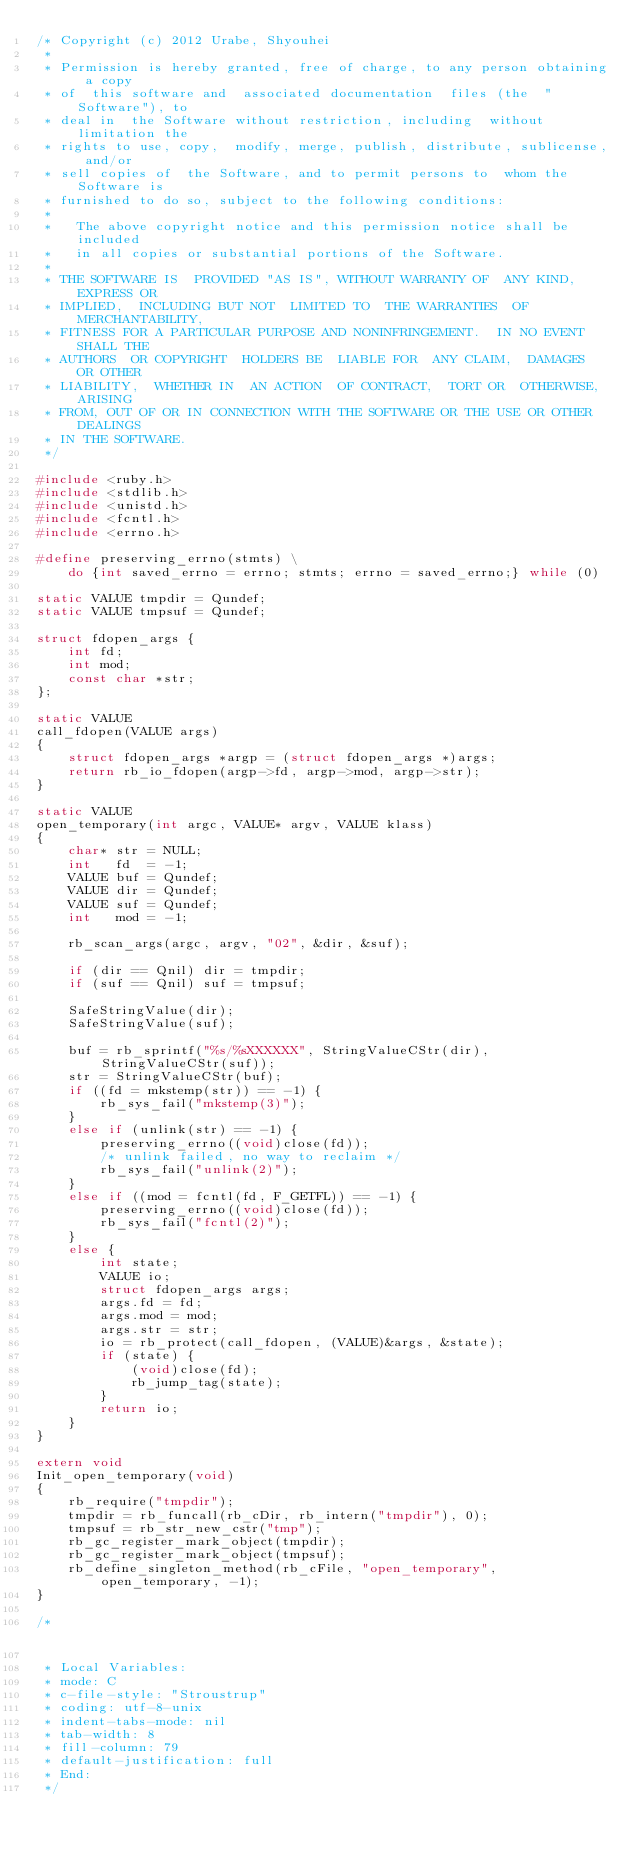<code> <loc_0><loc_0><loc_500><loc_500><_C_>/* Copyright (c) 2012 Urabe, Shyouhei
 *
 * Permission is hereby granted, free of charge, to any person obtaining a copy
 * of  this software and  associated documentation  files (the  "Software"), to
 * deal in  the Software without restriction, including  without limitation the
 * rights to use, copy,  modify, merge, publish, distribute, sublicense, and/or
 * sell copies of  the Software, and to permit persons to  whom the Software is
 * furnished to do so, subject to the following conditions:
 *
 *   The above copyright notice and this permission notice shall be included
 *   in all copies or substantial portions of the Software.
 *
 * THE SOFTWARE IS  PROVIDED "AS IS", WITHOUT WARRANTY OF  ANY KIND, EXPRESS OR
 * IMPLIED,  INCLUDING BUT NOT  LIMITED TO  THE WARRANTIES  OF MERCHANTABILITY,
 * FITNESS FOR A PARTICULAR PURPOSE AND NONINFRINGEMENT.  IN NO EVENT SHALL THE
 * AUTHORS  OR COPYRIGHT  HOLDERS BE  LIABLE FOR  ANY CLAIM,  DAMAGES  OR OTHER
 * LIABILITY,  WHETHER IN  AN ACTION  OF CONTRACT,  TORT OR  OTHERWISE, ARISING
 * FROM, OUT OF OR IN CONNECTION WITH THE SOFTWARE OR THE USE OR OTHER DEALINGS
 * IN THE SOFTWARE.
 */

#include <ruby.h>
#include <stdlib.h>
#include <unistd.h>
#include <fcntl.h>
#include <errno.h>

#define preserving_errno(stmts) \
	do {int saved_errno = errno; stmts; errno = saved_errno;} while (0)

static VALUE tmpdir = Qundef;
static VALUE tmpsuf = Qundef;

struct fdopen_args {
    int fd;
    int mod;
    const char *str;
};

static VALUE
call_fdopen(VALUE args)
{
    struct fdopen_args *argp = (struct fdopen_args *)args;
    return rb_io_fdopen(argp->fd, argp->mod, argp->str);
}

static VALUE
open_temporary(int argc, VALUE* argv, VALUE klass)
{
    char* str = NULL;
    int   fd  = -1;
    VALUE buf = Qundef;
    VALUE dir = Qundef;
    VALUE suf = Qundef;
    int   mod = -1;

    rb_scan_args(argc, argv, "02", &dir, &suf);

    if (dir == Qnil) dir = tmpdir;
    if (suf == Qnil) suf = tmpsuf;

    SafeStringValue(dir);
    SafeStringValue(suf);

    buf = rb_sprintf("%s/%sXXXXXX", StringValueCStr(dir), StringValueCStr(suf));
    str = StringValueCStr(buf);
    if ((fd = mkstemp(str)) == -1) {
        rb_sys_fail("mkstemp(3)");
    }
    else if (unlink(str) == -1) {
        preserving_errno((void)close(fd));
        /* unlink failed, no way to reclaim */
        rb_sys_fail("unlink(2)");
    }
    else if ((mod = fcntl(fd, F_GETFL)) == -1) {
        preserving_errno((void)close(fd));
        rb_sys_fail("fcntl(2)");
    }
    else {
        int state;
        VALUE io;
        struct fdopen_args args;
        args.fd = fd;
        args.mod = mod;
        args.str = str;
        io = rb_protect(call_fdopen, (VALUE)&args, &state);
        if (state) {
            (void)close(fd);
            rb_jump_tag(state);
        }
        return io;
    }
}

extern void
Init_open_temporary(void)
{
    rb_require("tmpdir");
    tmpdir = rb_funcall(rb_cDir, rb_intern("tmpdir"), 0);
    tmpsuf = rb_str_new_cstr("tmp");
    rb_gc_register_mark_object(tmpdir);
    rb_gc_register_mark_object(tmpsuf);
    rb_define_singleton_method(rb_cFile, "open_temporary", open_temporary, -1);
}

/* 
 * Local Variables:
 * mode: C
 * c-file-style: "Stroustrup"
 * coding: utf-8-unix
 * indent-tabs-mode: nil
 * tab-width: 8
 * fill-column: 79
 * default-justification: full
 * End:
 */
</code> 